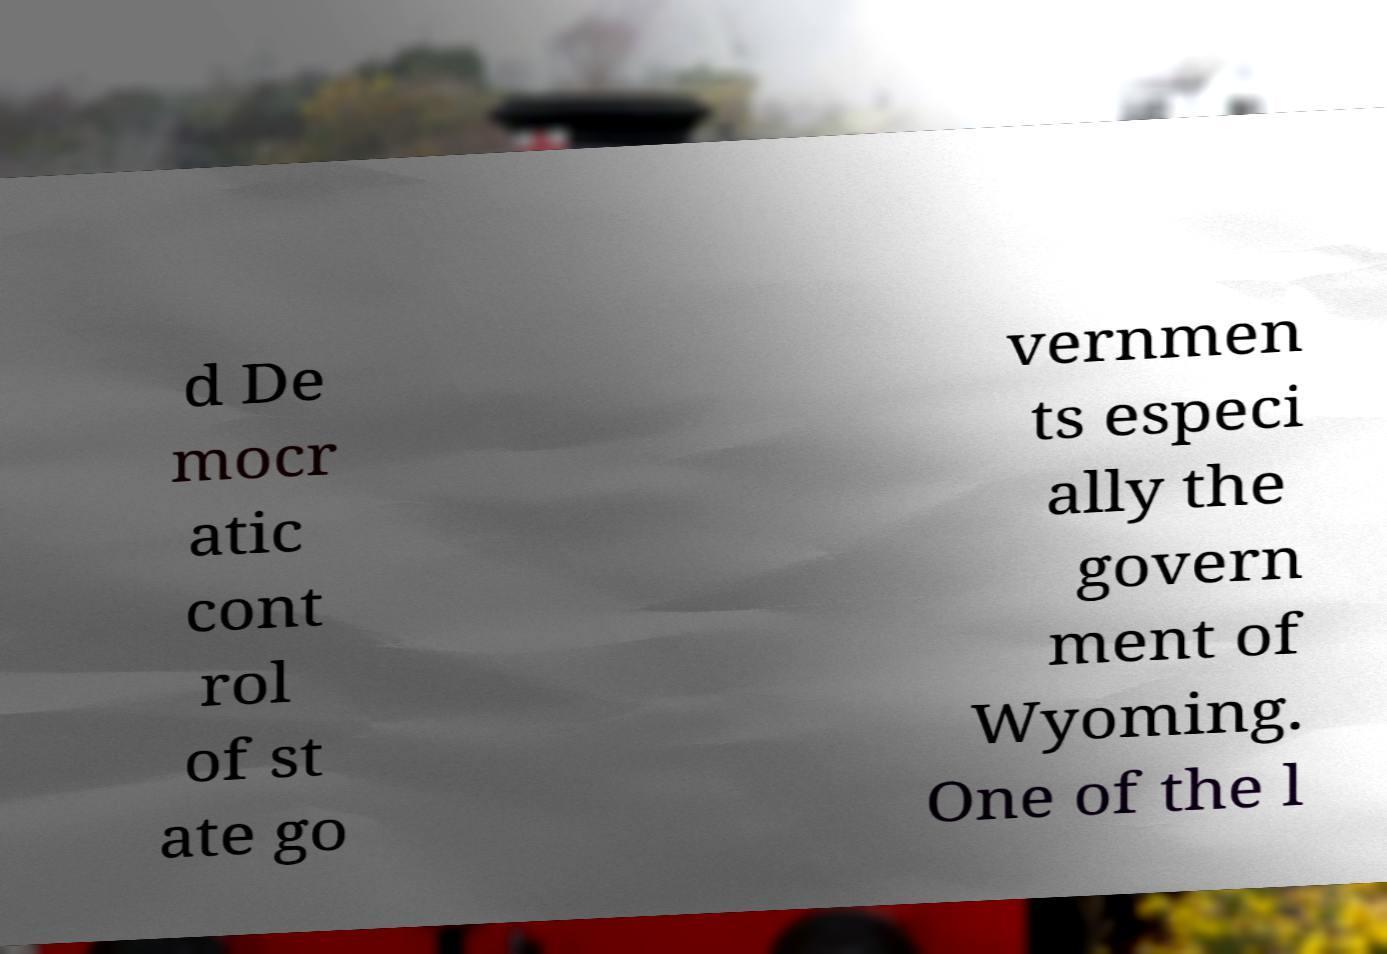There's text embedded in this image that I need extracted. Can you transcribe it verbatim? d De mocr atic cont rol of st ate go vernmen ts especi ally the govern ment of Wyoming. One of the l 